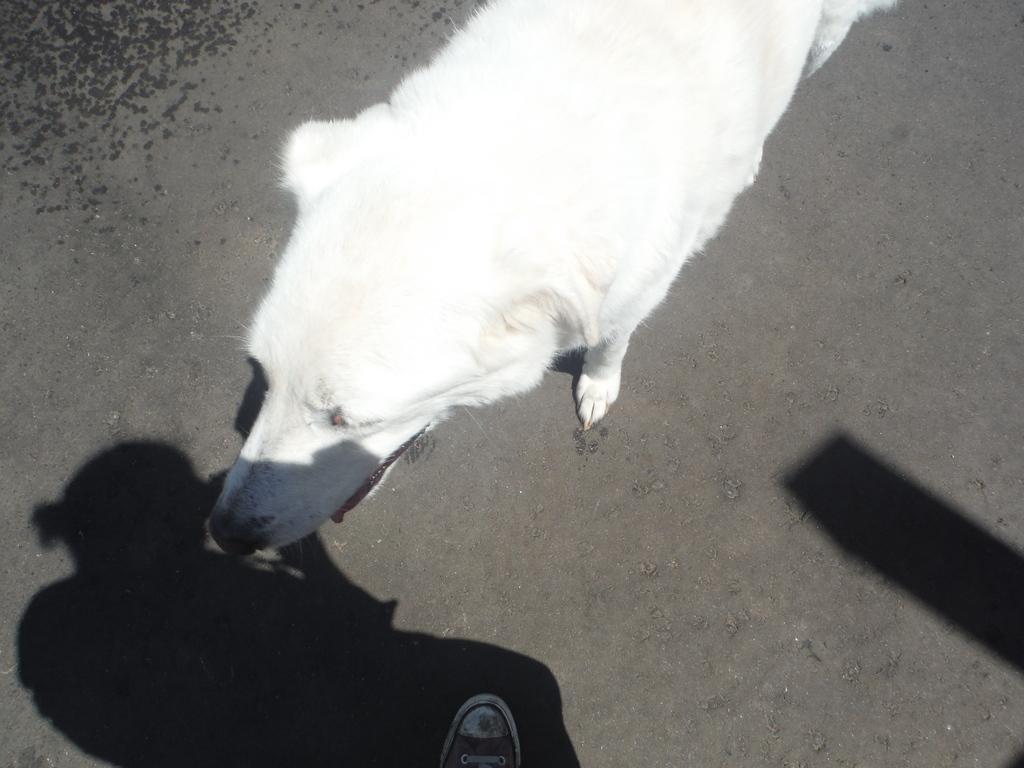Can you describe this image briefly? This picture shows a white dog on the road and we see a human leg and a shadow of human. 